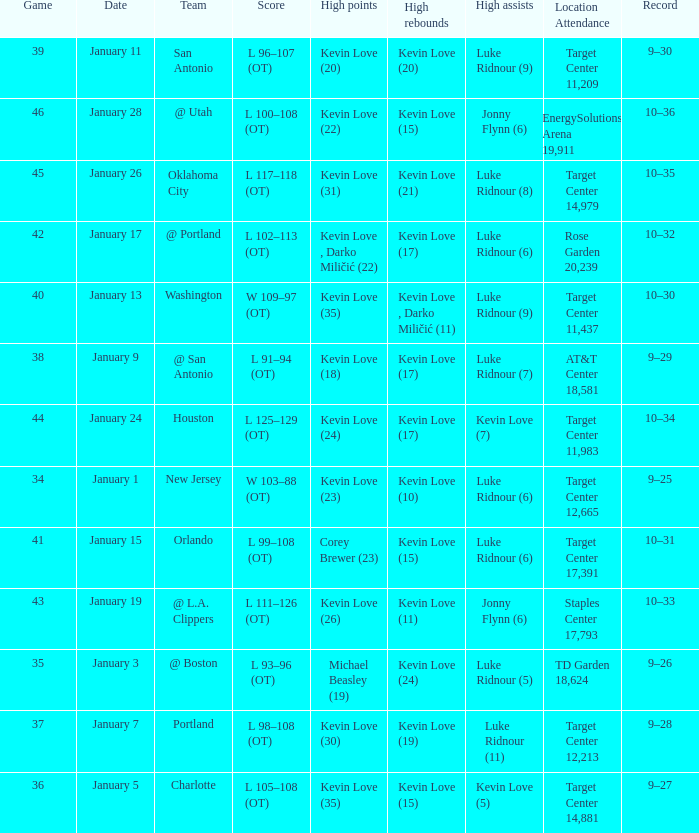How many times did kevin love (22) have the high points? 1.0. 